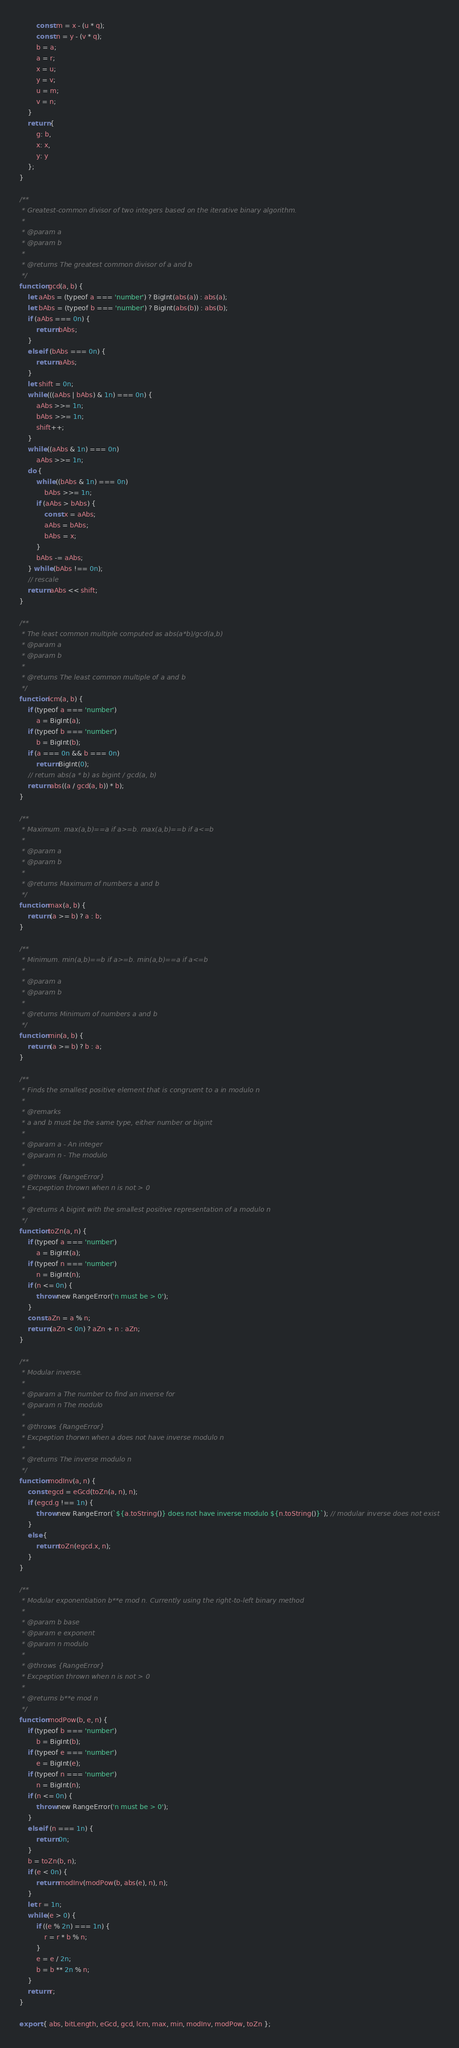Convert code to text. <code><loc_0><loc_0><loc_500><loc_500><_JavaScript_>        const m = x - (u * q);
        const n = y - (v * q);
        b = a;
        a = r;
        x = u;
        y = v;
        u = m;
        v = n;
    }
    return {
        g: b,
        x: x,
        y: y
    };
}

/**
 * Greatest-common divisor of two integers based on the iterative binary algorithm.
 *
 * @param a
 * @param b
 *
 * @returns The greatest common divisor of a and b
 */
function gcd(a, b) {
    let aAbs = (typeof a === 'number') ? BigInt(abs(a)) : abs(a);
    let bAbs = (typeof b === 'number') ? BigInt(abs(b)) : abs(b);
    if (aAbs === 0n) {
        return bAbs;
    }
    else if (bAbs === 0n) {
        return aAbs;
    }
    let shift = 0n;
    while (((aAbs | bAbs) & 1n) === 0n) {
        aAbs >>= 1n;
        bAbs >>= 1n;
        shift++;
    }
    while ((aAbs & 1n) === 0n)
        aAbs >>= 1n;
    do {
        while ((bAbs & 1n) === 0n)
            bAbs >>= 1n;
        if (aAbs > bAbs) {
            const x = aAbs;
            aAbs = bAbs;
            bAbs = x;
        }
        bAbs -= aAbs;
    } while (bAbs !== 0n);
    // rescale
    return aAbs << shift;
}

/**
 * The least common multiple computed as abs(a*b)/gcd(a,b)
 * @param a
 * @param b
 *
 * @returns The least common multiple of a and b
 */
function lcm(a, b) {
    if (typeof a === 'number')
        a = BigInt(a);
    if (typeof b === 'number')
        b = BigInt(b);
    if (a === 0n && b === 0n)
        return BigInt(0);
    // return abs(a * b) as bigint / gcd(a, b)
    return abs((a / gcd(a, b)) * b);
}

/**
 * Maximum. max(a,b)==a if a>=b. max(a,b)==b if a<=b
 *
 * @param a
 * @param b
 *
 * @returns Maximum of numbers a and b
 */
function max(a, b) {
    return (a >= b) ? a : b;
}

/**
 * Minimum. min(a,b)==b if a>=b. min(a,b)==a if a<=b
 *
 * @param a
 * @param b
 *
 * @returns Minimum of numbers a and b
 */
function min(a, b) {
    return (a >= b) ? b : a;
}

/**
 * Finds the smallest positive element that is congruent to a in modulo n
 *
 * @remarks
 * a and b must be the same type, either number or bigint
 *
 * @param a - An integer
 * @param n - The modulo
 *
 * @throws {RangeError}
 * Excpeption thrown when n is not > 0
 *
 * @returns A bigint with the smallest positive representation of a modulo n
 */
function toZn(a, n) {
    if (typeof a === 'number')
        a = BigInt(a);
    if (typeof n === 'number')
        n = BigInt(n);
    if (n <= 0n) {
        throw new RangeError('n must be > 0');
    }
    const aZn = a % n;
    return (aZn < 0n) ? aZn + n : aZn;
}

/**
 * Modular inverse.
 *
 * @param a The number to find an inverse for
 * @param n The modulo
 *
 * @throws {RangeError}
 * Excpeption thorwn when a does not have inverse modulo n
 *
 * @returns The inverse modulo n
 */
function modInv(a, n) {
    const egcd = eGcd(toZn(a, n), n);
    if (egcd.g !== 1n) {
        throw new RangeError(`${a.toString()} does not have inverse modulo ${n.toString()}`); // modular inverse does not exist
    }
    else {
        return toZn(egcd.x, n);
    }
}

/**
 * Modular exponentiation b**e mod n. Currently using the right-to-left binary method
 *
 * @param b base
 * @param e exponent
 * @param n modulo
 *
 * @throws {RangeError}
 * Excpeption thrown when n is not > 0
 *
 * @returns b**e mod n
 */
function modPow(b, e, n) {
    if (typeof b === 'number')
        b = BigInt(b);
    if (typeof e === 'number')
        e = BigInt(e);
    if (typeof n === 'number')
        n = BigInt(n);
    if (n <= 0n) {
        throw new RangeError('n must be > 0');
    }
    else if (n === 1n) {
        return 0n;
    }
    b = toZn(b, n);
    if (e < 0n) {
        return modInv(modPow(b, abs(e), n), n);
    }
    let r = 1n;
    while (e > 0) {
        if ((e % 2n) === 1n) {
            r = r * b % n;
        }
        e = e / 2n;
        b = b ** 2n % n;
    }
    return r;
}

export { abs, bitLength, eGcd, gcd, lcm, max, min, modInv, modPow, toZn };</code> 